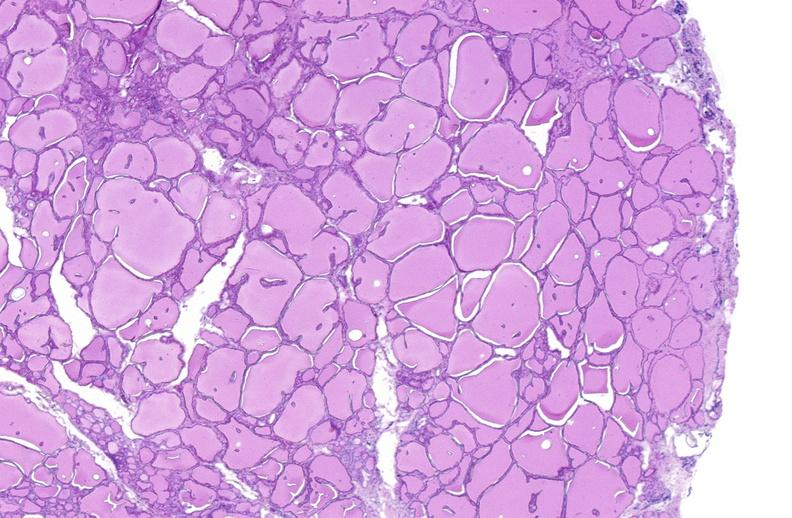where is this part in the figure?
Answer the question using a single word or phrase. Endocrine system 